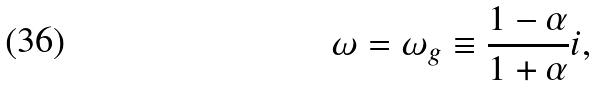Convert formula to latex. <formula><loc_0><loc_0><loc_500><loc_500>\omega = \omega _ { g } \equiv \frac { 1 - \alpha } { 1 + \alpha } i ,</formula> 